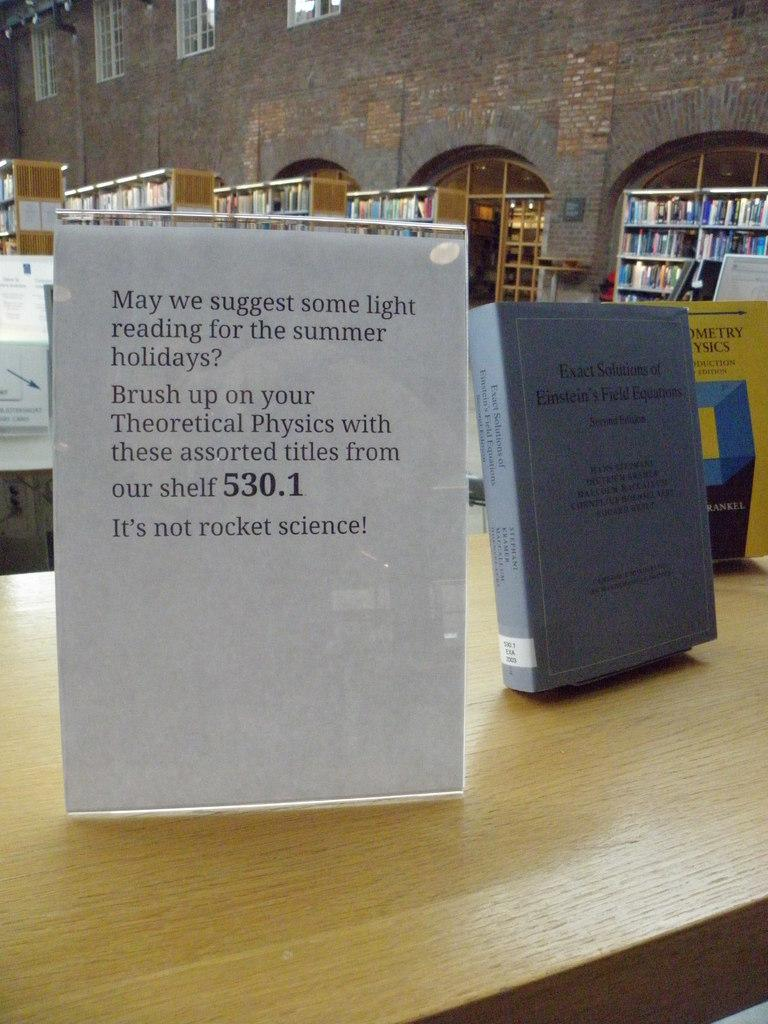Provide a one-sentence caption for the provided image. a sign inside a library says May we Suggest some light reading. 